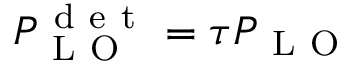Convert formula to latex. <formula><loc_0><loc_0><loc_500><loc_500>P _ { L O } ^ { d e t } = \tau P _ { L O }</formula> 